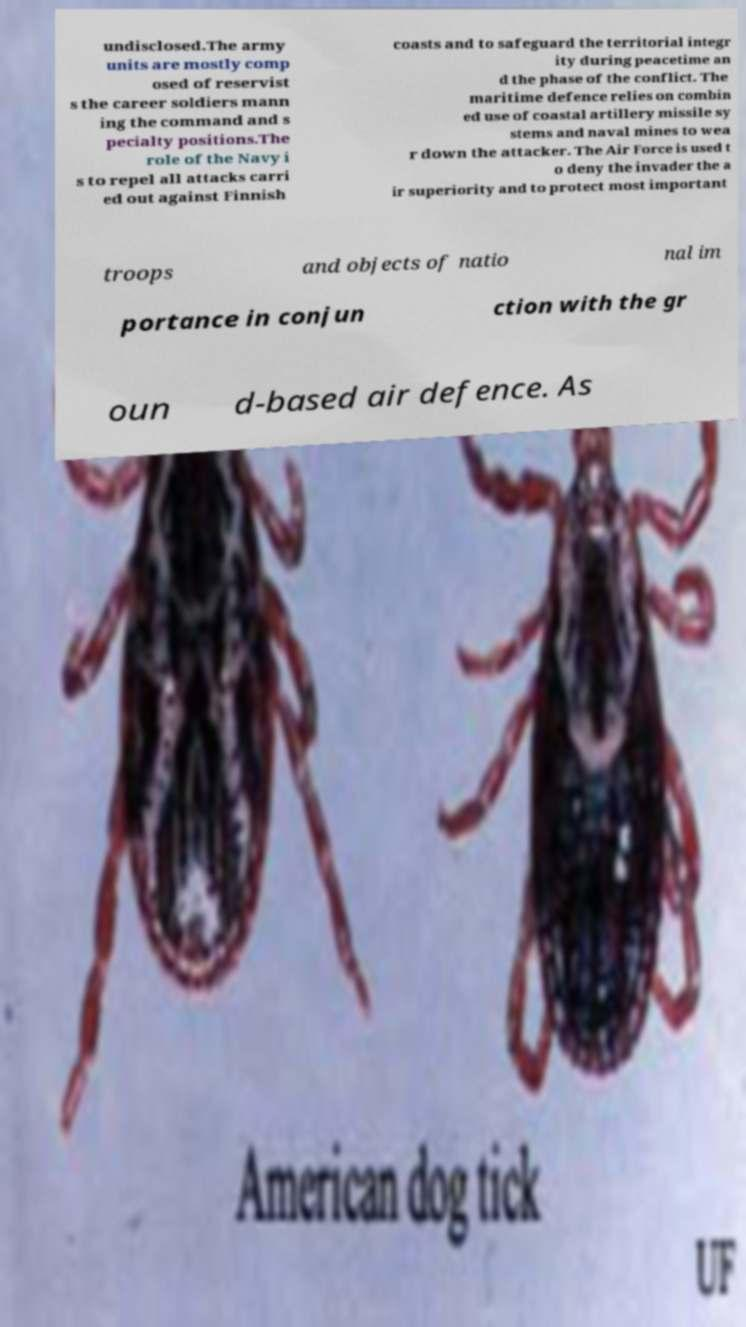Please identify and transcribe the text found in this image. undisclosed.The army units are mostly comp osed of reservist s the career soldiers mann ing the command and s pecialty positions.The role of the Navy i s to repel all attacks carri ed out against Finnish coasts and to safeguard the territorial integr ity during peacetime an d the phase of the conflict. The maritime defence relies on combin ed use of coastal artillery missile sy stems and naval mines to wea r down the attacker. The Air Force is used t o deny the invader the a ir superiority and to protect most important troops and objects of natio nal im portance in conjun ction with the gr oun d-based air defence. As 